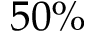<formula> <loc_0><loc_0><loc_500><loc_500>5 0 \%</formula> 